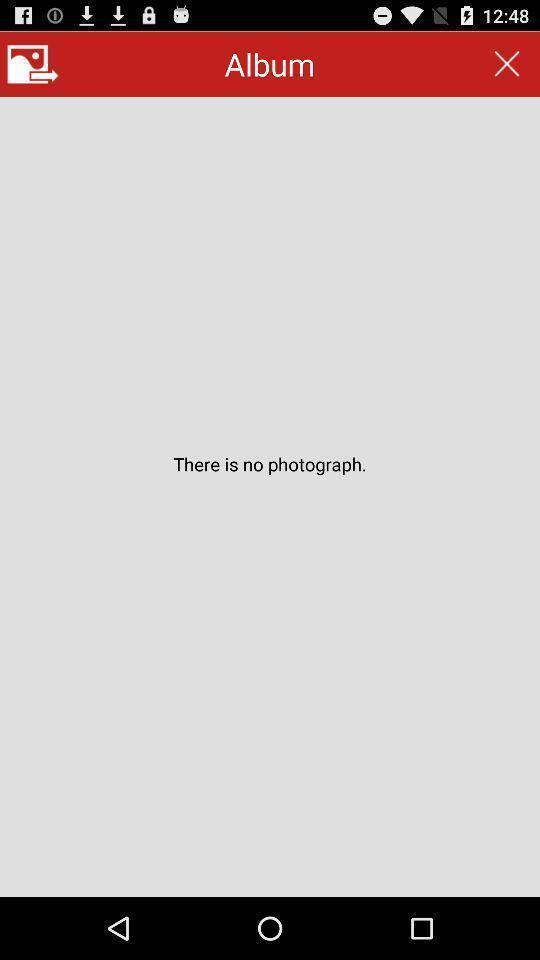Provide a description of this screenshot. Screen shows the album of an application. 